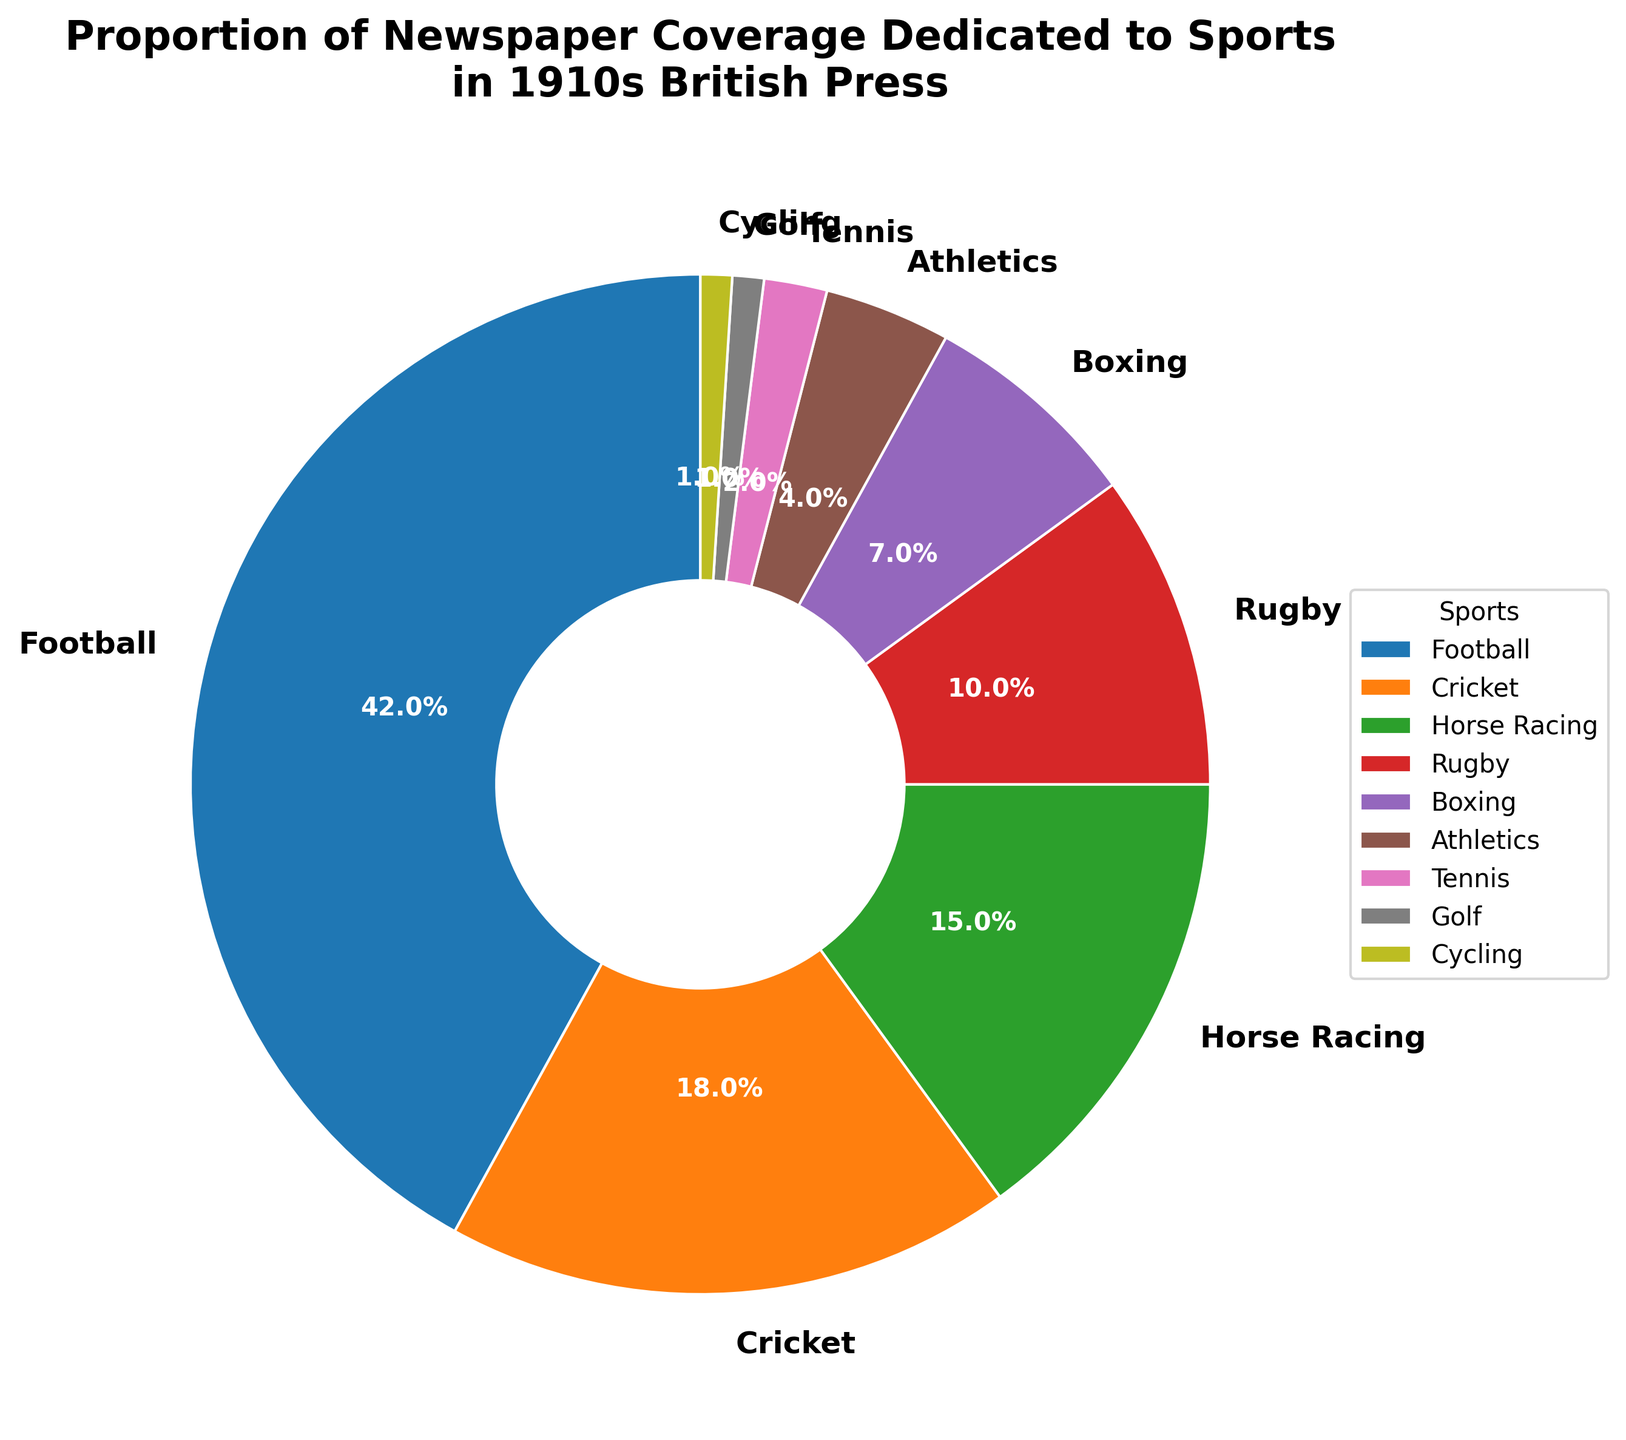What sport had the highest newspaper coverage in the 1910s? The pie chart shows that the wedge for football is the largest and labeled with the highest percentage. Therefore, football had the highest coverage.
Answer: Football Which two sports combined have a coverage percentage greater than horse racing? The pie chart shows the coverage percentages. Cricket (18%) and Rugby (10%) combined sum to 28%, which is greater than Horse Racing's 15%.
Answer: Cricket and Rugby What is the total percentage of newspaper coverage for athletics, tennis, golf, and cycling? Sum the percentages for Athletics (4%), Tennis (2%), Golf (1%), and Cycling (1%): 4+2+1+1 = 8%.
Answer: 8% Which sport has the second least coverage after cycling? Based on the percentages shown, Cycling has the least coverage at 1%. The next smallest segment is Golf, also at 1%, but since Golf is technically tied with Cycling, the sport with the next higher coverage is Tennis at 2%.
Answer: Tennis Is cricket's coverage more than double that of boxing's? Cricket's coverage is 18%, and Boxing's is 7%. Double of Boxing's coverage would be 7 * 2 = 14%. Since 18% is more than 14%, Cricket's coverage is indeed more than double Boxing's.
Answer: Yes How does the combined coverage of rugby and boxing compare to football's coverage? Rugby's coverage is 10%, and Boxing's is 7%, summing to 17%. Football's coverage is 42%. Therefore, Football's coverage is much higher than the combined coverage of Rugby and Boxing.
Answer: Football's coverage is higher What is the coverage percentage difference between the sport with the highest coverage and cricket? Football has the highest coverage at 42%. Cricket has 18%. The difference is 42 - 18 = 24%.
Answer: 24% Which segment is represented by a blue color in the pie chart? The largest segment is football, which covers 42% and is depicted in the blue color as described in the visual attributes.
Answer: Football Compare the proportion of newspaper coverage between horse racing and rugby. Which one has more coverage and by what percentage? Horse Racing has 15% coverage, while Rugby has 10%. The difference is 15 - 10 = 5%, meaning Horse Racing has 5% more coverage than Rugby.
Answer: Horse Racing, 5% Order the sports with greater than 10% coverage from highest to lowest. First, identify sports with more than 10% coverage: Football (42%), Cricket (18%), Horse Racing (15%), Rugby (10%). Then order them: Football, Cricket, Horse Racing, Rugby.
Answer: Football, Cricket, Horse Racing, Rugby 